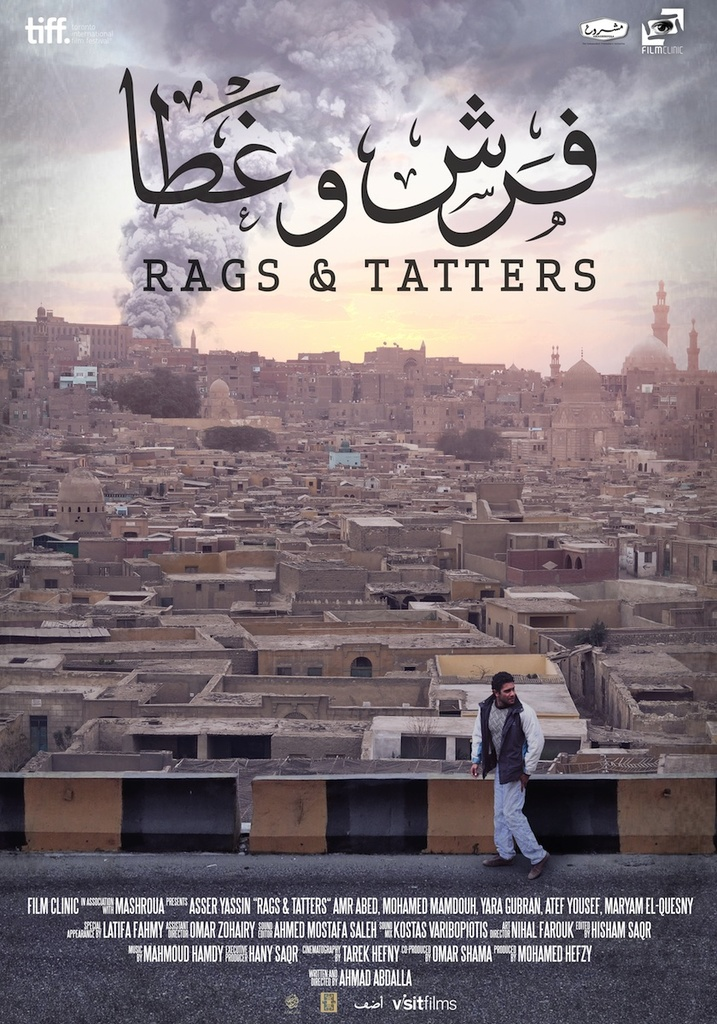Can you elaborate on the elements of the picture provided? The image is a movie poster for the film "Rags & Tatters," showcased at the Toronto International Film Festival. The poster features a man standing on a rooftop, with the sprawling cityscape behind him, dominated by warm tones and historical architecture, hinting at a setting rich in history and culture. 'Rags & Tatters' and its Arabic equivalent 'جال و خرجة' are prominently displayed, suggesting significant themes of disparity or struggle. The company 'Film Clinic' and key figures such as Amir Abed, Mahmoud Hemeda, and Yousra El Lozy are mentioned, underscoring their pivotal roles. The design elements, such as the dominant mosque in the backdrop and the overall dusky, earthy color scheme, potentially reflect the socio-cultural backdrop and the mood of the narrative, inviting the viewer into a story set in an urban, possibly Middle-Eastern environment. 